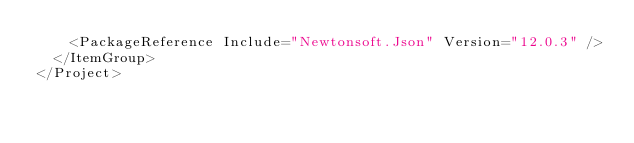<code> <loc_0><loc_0><loc_500><loc_500><_XML_>    <PackageReference Include="Newtonsoft.Json" Version="12.0.3" />
  </ItemGroup>
</Project>
</code> 